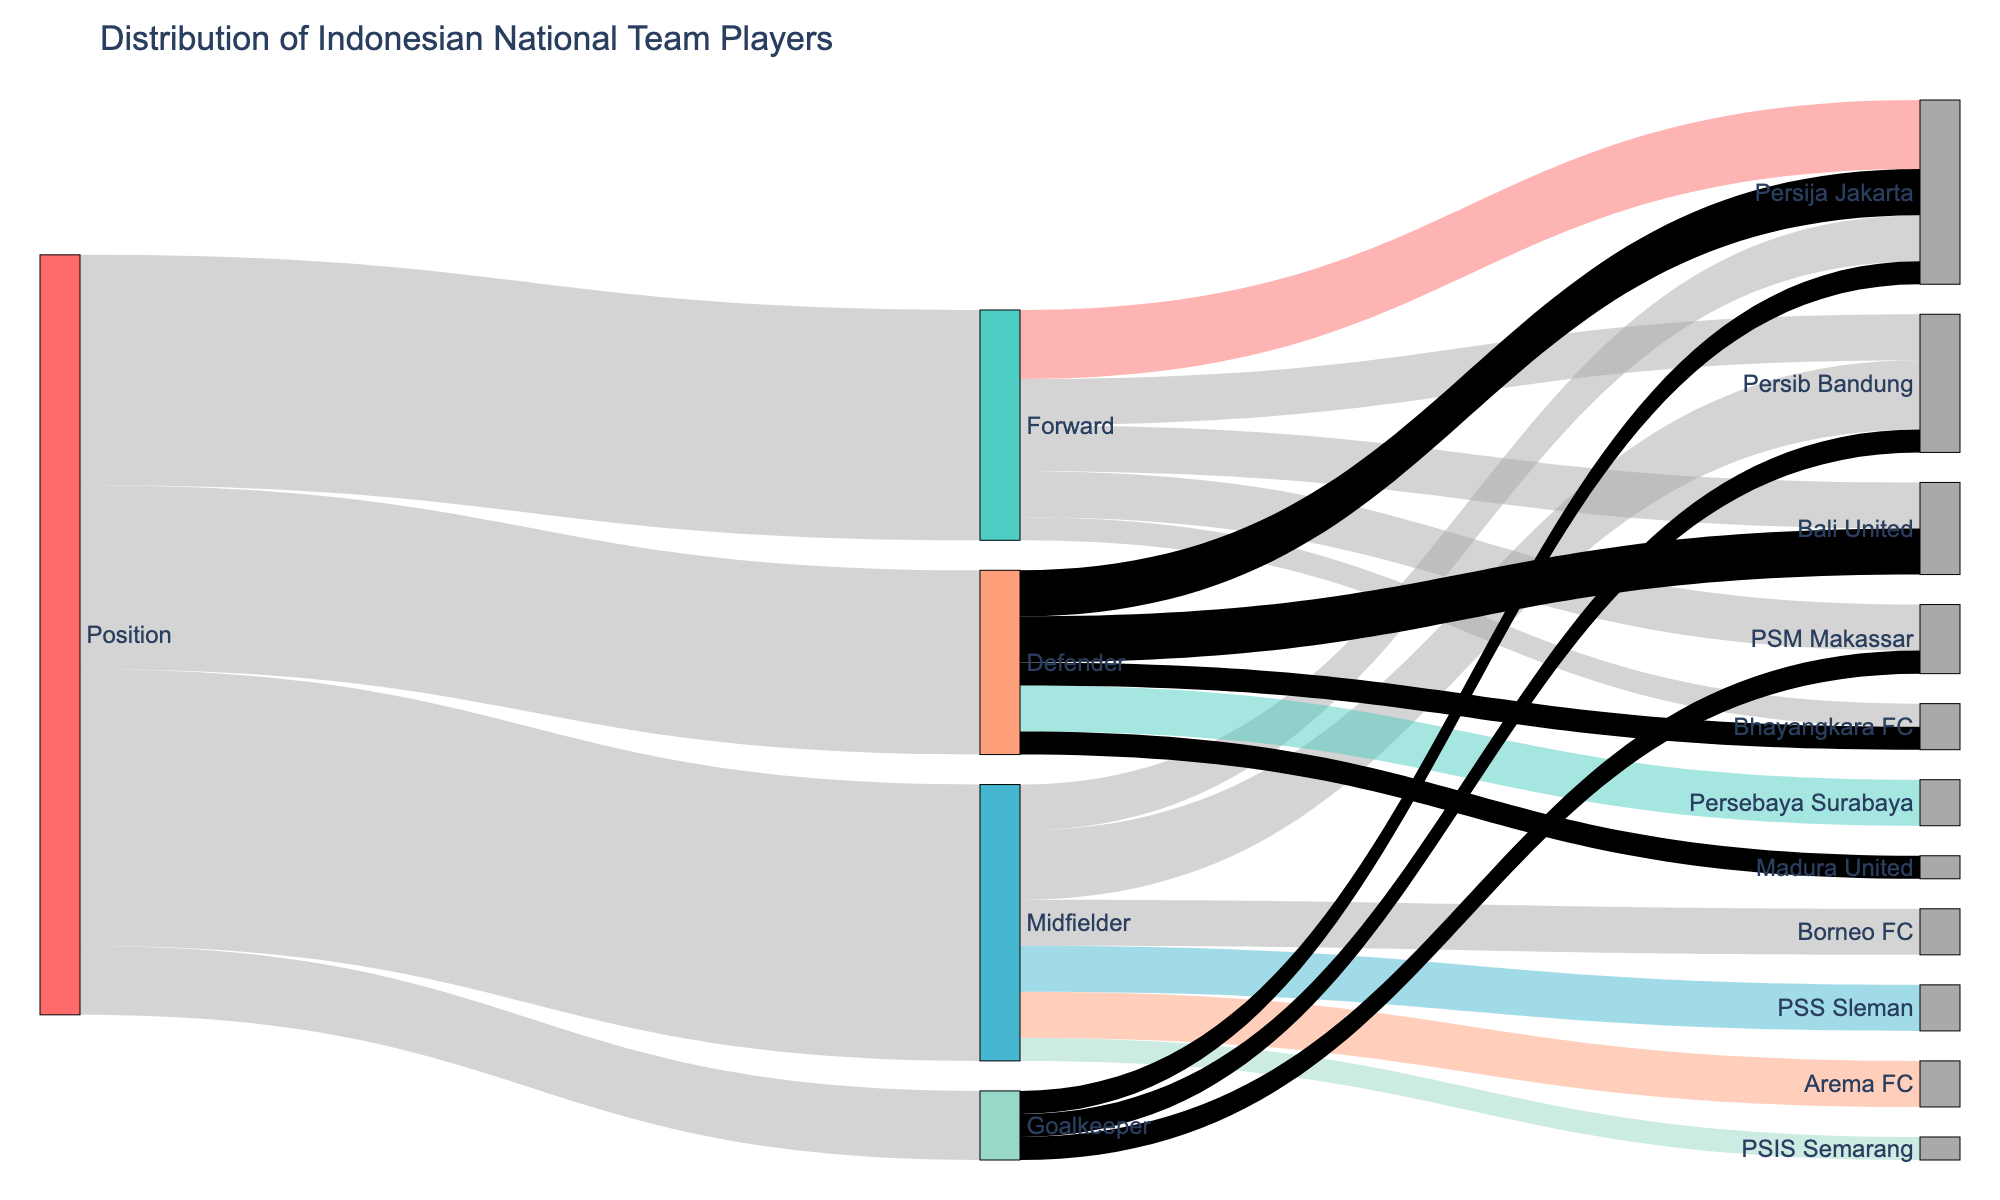What is the title of the Sankey diagram? The title is typically located at the top of the diagram and summarizes the content of the figure. In this case, it reads "Distribution of Indonesian National Team Players".
Answer: Distribution of Indonesian National Team Players How many player positions are displayed in the diagram? Look for the initial nodes that connect to specific player roles in the diagram. Here, the positions: Forward, Midfielder, Defender, and Goalkeeper are shown.
Answer: 4 Which club has the highest number of forwards? Trace the flows from "Forward" to various clubs. Persija Jakarta connects to three players, the highest for the Forward position.
Answer: Persija Jakarta How many defenders are there in total? The flow from the "Defender" node sums up to eight. The connection percentages represent the individual values, and the total sum for defenders is 8.
Answer: 8 What is the total number of players who are affiliated with Persija Jakarta? Identify all flows that end in "Persija Jakarta". They encompass 3 (Forward) + 2 (Midfielder) + 2 (Defender) + 1 (Goalkeeper), giving a total of 8 players.
Answer: 8 Which club has players distributed across the most positions? Examine the clubs in the target nodes to see how many different positions direct flows to them. Persija Jakarta has players from Forward, Midfielder, Defender, and Goalkeeper, making it four positions.
Answer: Persija Jakarta Is there any club that has players solely from one position? Which club and position? Look for clubs that have flows from only one source. For example, Madura United only has defenders (1 value).
Answer: Madura United, Defender How many players are affiliated with clubs other than the three explicit affiliations given for goalkeepers? The goalkeepers are affiliated with Persib Bandung, Persija Jakarta, and PSM Makassar, each with one, totaling three. No other clubs are listed for goalkeepers.
Answer: 0 What is the combined number of players in Persib Bandung across all positions? Follow the flows from each position to Persib Bandung: 2 (Forward) + 3 (Midfielder) + 1 (Goalkeeper). The total sum is 6 players.
Answer: 6 Compare the number of players from Persija Jakarta and PSM Makassar. Which club has more players overall? Summing up players for Persija Jakarta: 3 (Forward) + 2 (Midfielder) + 2 (Defender) + 1 (Goalkeeper) = 8 and for PSM Makassar: 2 (Forward) + 1 (Goalkeeper) = 3. Persija Jakarta has more players.
Answer: Persija Jakarta 